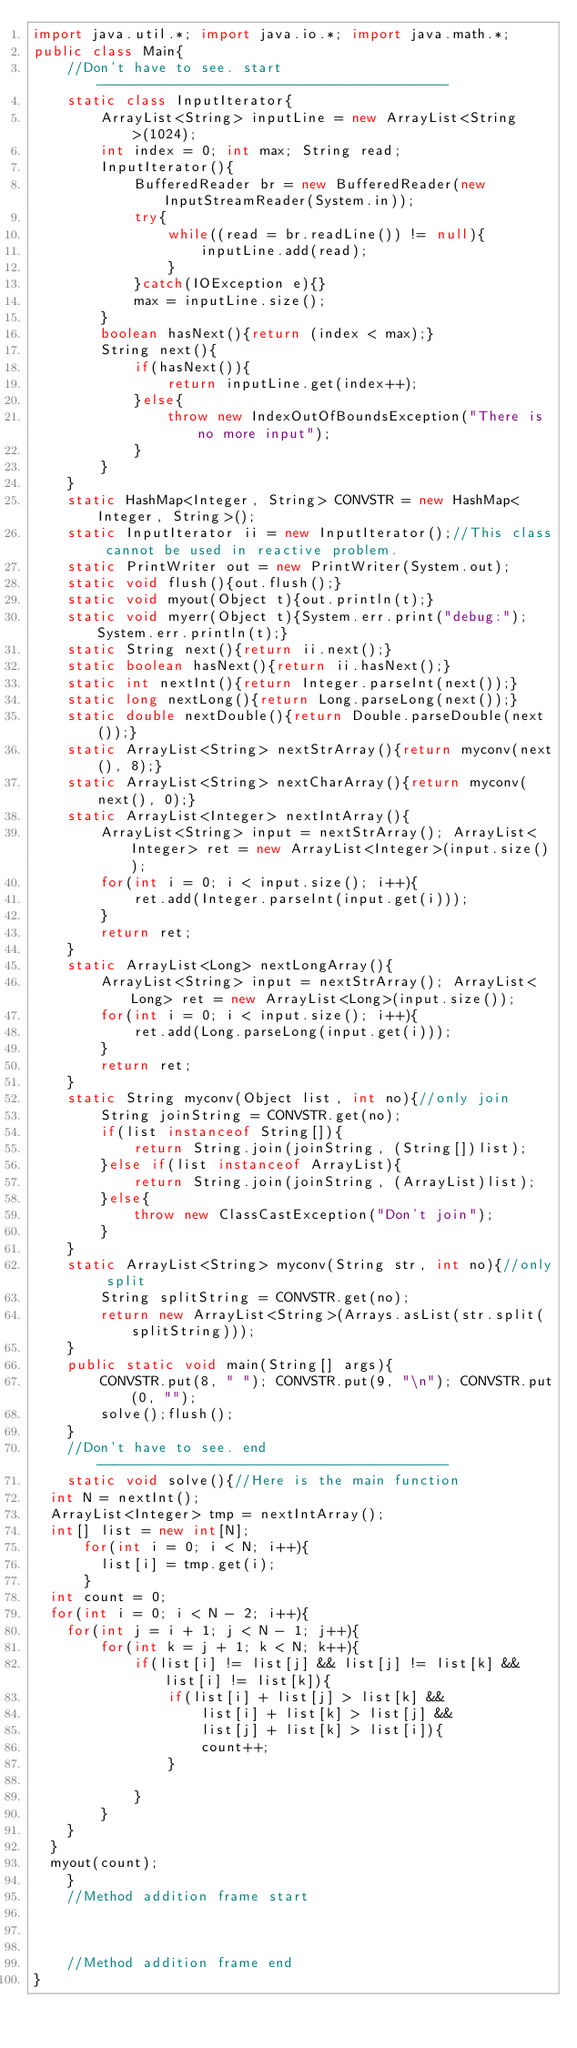Convert code to text. <code><loc_0><loc_0><loc_500><loc_500><_Java_>import java.util.*; import java.io.*; import java.math.*;
public class Main{
	//Don't have to see. start------------------------------------------
	static class InputIterator{
		ArrayList<String> inputLine = new ArrayList<String>(1024);
		int index = 0; int max; String read;
		InputIterator(){
			BufferedReader br = new BufferedReader(new InputStreamReader(System.in));
			try{
				while((read = br.readLine()) != null){
					inputLine.add(read);
				}
			}catch(IOException e){}
			max = inputLine.size();
		}
		boolean hasNext(){return (index < max);}
		String next(){
			if(hasNext()){
				return inputLine.get(index++);
			}else{
				throw new IndexOutOfBoundsException("There is no more input");
			}
		}
	}
	static HashMap<Integer, String> CONVSTR = new HashMap<Integer, String>();
	static InputIterator ii = new InputIterator();//This class cannot be used in reactive problem.
	static PrintWriter out = new PrintWriter(System.out);
	static void flush(){out.flush();}
	static void myout(Object t){out.println(t);}
	static void myerr(Object t){System.err.print("debug:");System.err.println(t);}
	static String next(){return ii.next();}
	static boolean hasNext(){return ii.hasNext();}
	static int nextInt(){return Integer.parseInt(next());}
	static long nextLong(){return Long.parseLong(next());}
	static double nextDouble(){return Double.parseDouble(next());}
	static ArrayList<String> nextStrArray(){return myconv(next(), 8);}
	static ArrayList<String> nextCharArray(){return myconv(next(), 0);}
	static ArrayList<Integer> nextIntArray(){
		ArrayList<String> input = nextStrArray(); ArrayList<Integer> ret = new ArrayList<Integer>(input.size());
		for(int i = 0; i < input.size(); i++){
			ret.add(Integer.parseInt(input.get(i)));
		}
		return ret;
	}
	static ArrayList<Long> nextLongArray(){
		ArrayList<String> input = nextStrArray(); ArrayList<Long> ret = new ArrayList<Long>(input.size());
		for(int i = 0; i < input.size(); i++){
			ret.add(Long.parseLong(input.get(i)));
		}
		return ret;
	}
	static String myconv(Object list, int no){//only join
		String joinString = CONVSTR.get(no);
		if(list instanceof String[]){
			return String.join(joinString, (String[])list);
		}else if(list instanceof ArrayList){
			return String.join(joinString, (ArrayList)list);
		}else{
			throw new ClassCastException("Don't join");
		}
	}
	static ArrayList<String> myconv(String str, int no){//only split
		String splitString = CONVSTR.get(no);
		return new ArrayList<String>(Arrays.asList(str.split(splitString)));
	}
	public static void main(String[] args){
		CONVSTR.put(8, " "); CONVSTR.put(9, "\n"); CONVSTR.put(0, "");
		solve();flush();
	}
	//Don't have to see. end------------------------------------------
	static void solve(){//Here is the main function
  int N = nextInt();
  ArrayList<Integer> tmp = nextIntArray();
  int[] list = new int[N];
      for(int i = 0; i < N; i++){
        list[i] = tmp.get(i);
      }
  int count = 0;
  for(int i = 0; i < N - 2; i++){
  	for(int j = i + 1; j < N - 1; j++){
  		for(int k = j + 1; k < N; k++){
  			if(list[i] != list[j] && list[j] != list[k] && list[i] != list[k]){
  				if(list[i] + list[j] > list[k] && 
  					list[i] + list[k] > list[j] && 
  					list[j] + list[k] > list[i]){
  					count++;
  				}
  				
  			}
  		}
  	}
  }
  myout(count);
	}
	//Method addition frame start



	//Method addition frame end
}
</code> 